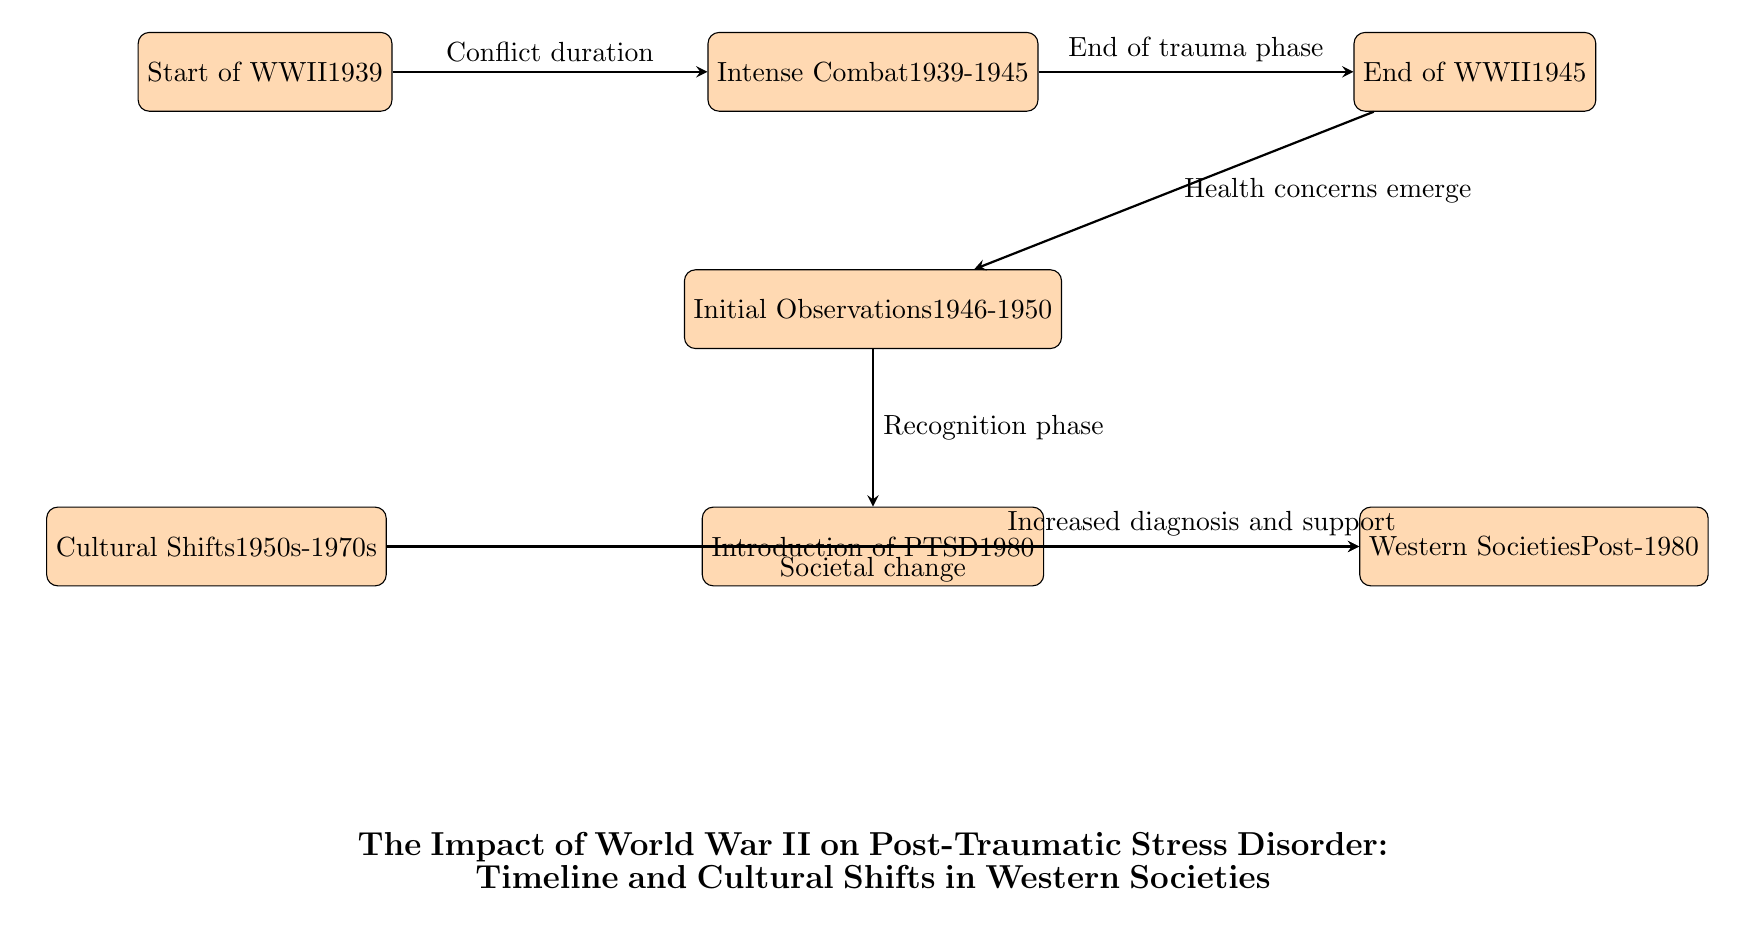What event started in 1939? The diagram indicates that the start of World War II occurred in 1939, as reflected in the first node.
Answer: Start of WWII What years correspond to the intense combat phase? The second node specifies that intense combat took place from 1939 to 1945, as it is labeled in that manner directly.
Answer: 1939-1945 What happened immediately after the end of WWII? According to the diagram, the end of WWII in 1945 led to a phase where health concerns emerged, shown in the following node.
Answer: Health concerns emerge When was PTSD introduced as a diagnosis? The diagram shows that PTSD was introduced in 1980, which is directly indicated in the relevant node.
Answer: 1980 What societal changes occurred between the 1950s and 1970s? The diagram refers to cultural shifts between the 1950s and 1970s as pertinent to the evolution of societal attitudes towards trauma and mental health, as specified in the node.
Answer: Cultural Shifts How did the health concerns observed after WWII relate to PTSD? The flow from the end of WWII suggests that the recognition of health concerns was a precursor to the introduction of PTSD in 1980, indicating that these health concerns were influential in this development.
Answer: Recognition phase How did increased diagnosis and support for PTSD evolve post-1980? The diagram shows that after PTSD was introduced in 1980, there was a noted increase in diagnosis and support, suggesting a growing awareness and response to this condition in Western societies.
Answer: Increased diagnosis and support What is the main focus of the diagram? The overarching theme of the diagram is reflected in the title, which discusses the impact of WWII and its relation to PTSD and cultural shifts. This title encapsulates the entire narrative presented in the diagram.
Answer: The Impact of World War II on Post-Traumatic Stress Disorder What type of diagram is this? The structure and purpose of the diagram, which organizes a timeline and cultural responses, classify it specifically as a textbook diagram, providing educational insights on its subject matter.
Answer: Textbook Diagram 